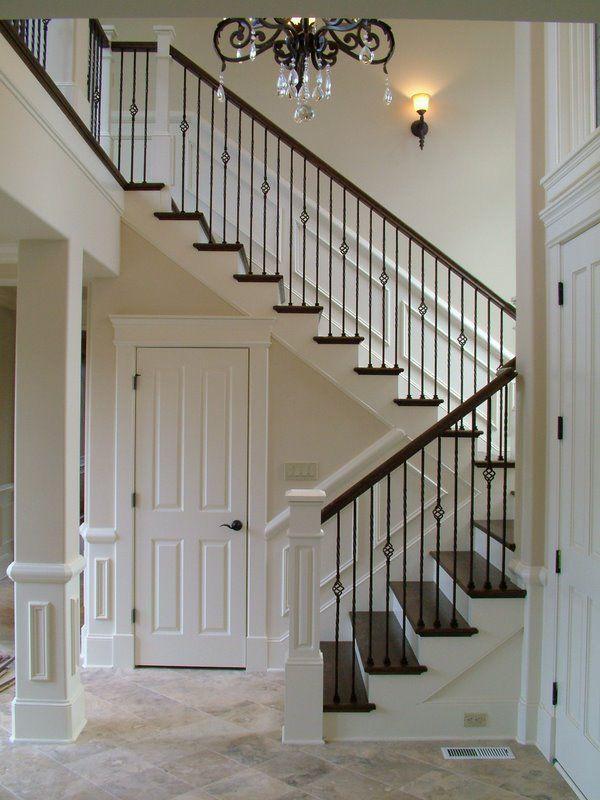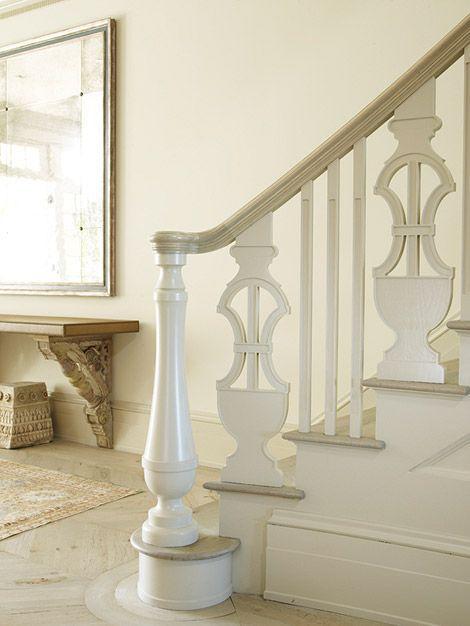The first image is the image on the left, the second image is the image on the right. For the images displayed, is the sentence "The left image shows a curving staircase with a curving rail on the right side." factually correct? Answer yes or no. No. 